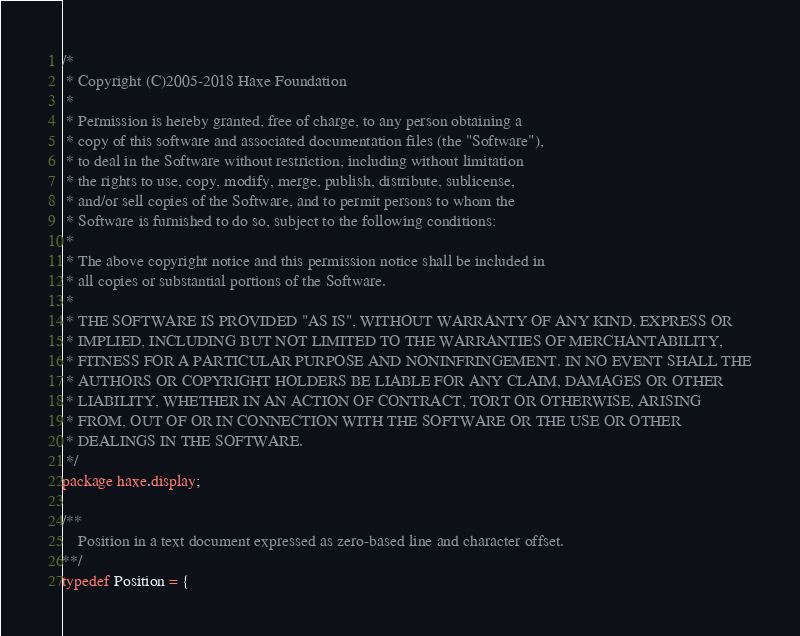Convert code to text. <code><loc_0><loc_0><loc_500><loc_500><_Haxe_>/*
 * Copyright (C)2005-2018 Haxe Foundation
 *
 * Permission is hereby granted, free of charge, to any person obtaining a
 * copy of this software and associated documentation files (the "Software"),
 * to deal in the Software without restriction, including without limitation
 * the rights to use, copy, modify, merge, publish, distribute, sublicense,
 * and/or sell copies of the Software, and to permit persons to whom the
 * Software is furnished to do so, subject to the following conditions:
 *
 * The above copyright notice and this permission notice shall be included in
 * all copies or substantial portions of the Software.
 *
 * THE SOFTWARE IS PROVIDED "AS IS", WITHOUT WARRANTY OF ANY KIND, EXPRESS OR
 * IMPLIED, INCLUDING BUT NOT LIMITED TO THE WARRANTIES OF MERCHANTABILITY,
 * FITNESS FOR A PARTICULAR PURPOSE AND NONINFRINGEMENT. IN NO EVENT SHALL THE
 * AUTHORS OR COPYRIGHT HOLDERS BE LIABLE FOR ANY CLAIM, DAMAGES OR OTHER
 * LIABILITY, WHETHER IN AN ACTION OF CONTRACT, TORT OR OTHERWISE, ARISING
 * FROM, OUT OF OR IN CONNECTION WITH THE SOFTWARE OR THE USE OR OTHER
 * DEALINGS IN THE SOFTWARE.
 */
package haxe.display;

/**
    Position in a text document expressed as zero-based line and character offset.
**/
typedef Position = {</code> 